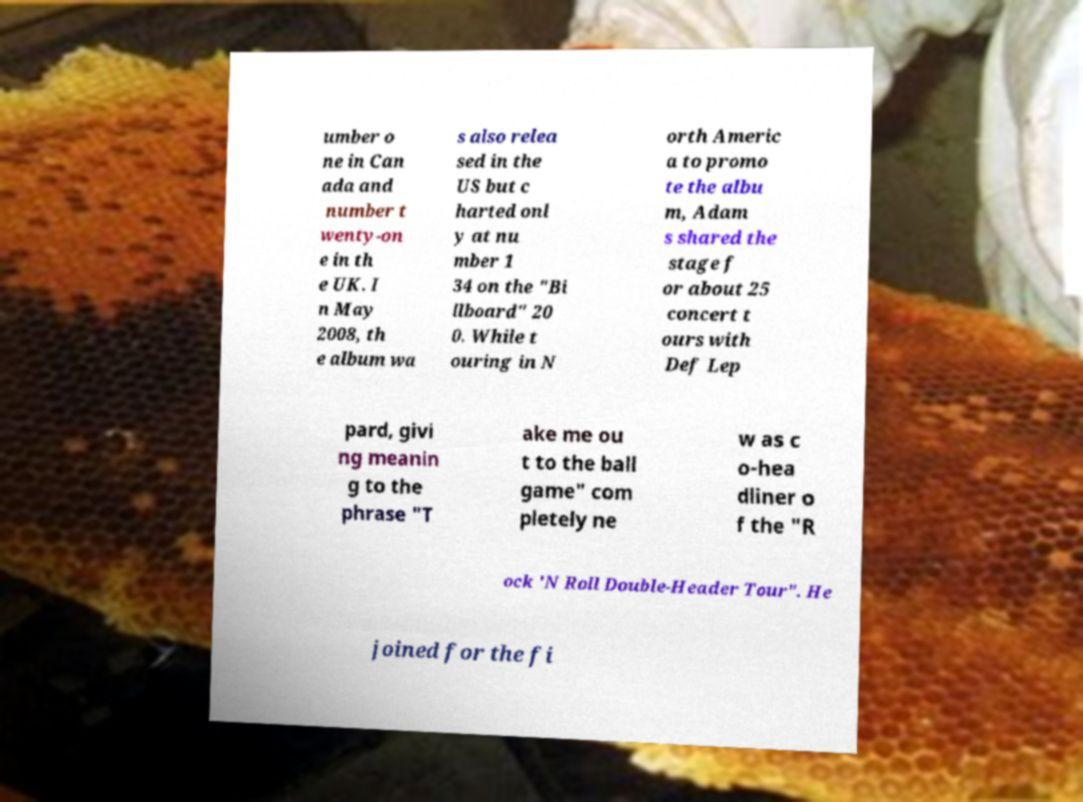For documentation purposes, I need the text within this image transcribed. Could you provide that? umber o ne in Can ada and number t wenty-on e in th e UK. I n May 2008, th e album wa s also relea sed in the US but c harted onl y at nu mber 1 34 on the "Bi llboard" 20 0. While t ouring in N orth Americ a to promo te the albu m, Adam s shared the stage f or about 25 concert t ours with Def Lep pard, givi ng meanin g to the phrase "T ake me ou t to the ball game" com pletely ne w as c o-hea dliner o f the "R ock 'N Roll Double-Header Tour". He joined for the fi 